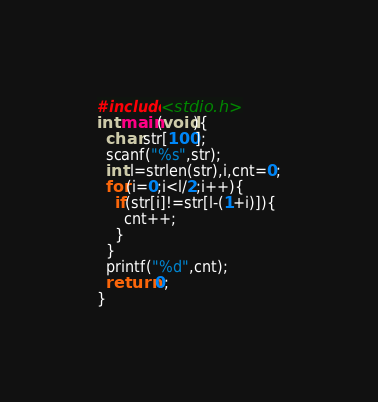<code> <loc_0><loc_0><loc_500><loc_500><_C_>#include<stdio.h>
int main(void){
  char str[100];
  scanf("%s",str);
  int l=strlen(str),i,cnt=0;
  for(i=0;i<l/2;i++){
    if(str[i]!=str[l-(1+i)]){
      cnt++;
    }
  }
  printf("%d",cnt);
  return 0;
}
</code> 